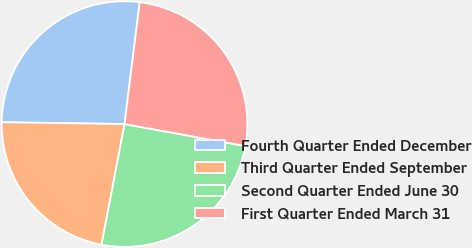Convert chart. <chart><loc_0><loc_0><loc_500><loc_500><pie_chart><fcel>Fourth Quarter Ended December<fcel>Third Quarter Ended September<fcel>Second Quarter Ended June 30<fcel>First Quarter Ended March 31<nl><fcel>26.73%<fcel>22.24%<fcel>25.13%<fcel>25.89%<nl></chart> 